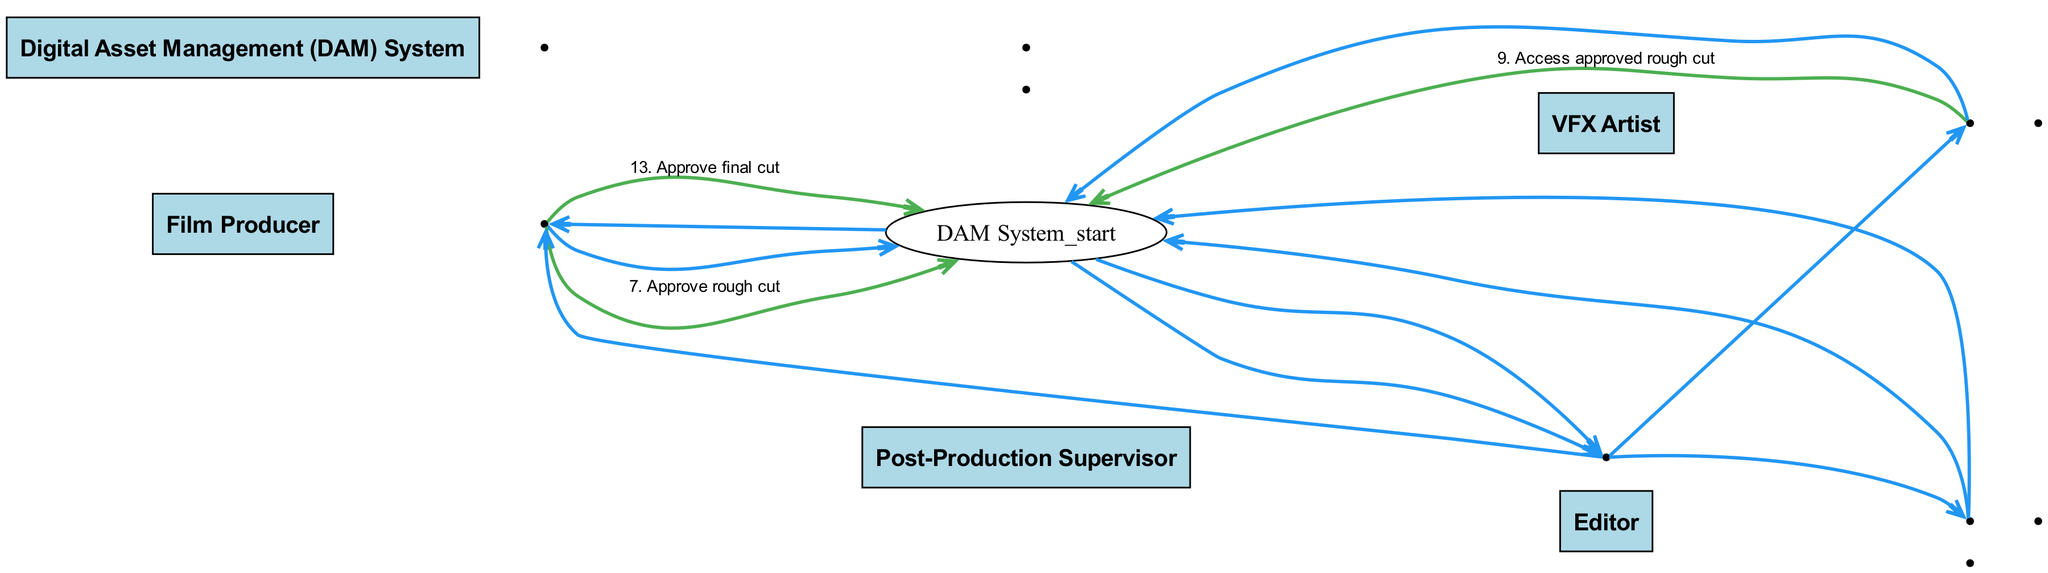What action does the Film Producer take first? The Film Producer initiates the process by uploading raw footage to the Digital Asset Management System. This is the first action in the sequence diagram.
Answer: Upload raw footage How many total actions are depicted in the sequence? The sequence consists of 13 actions represented by edges connecting different actors. These actions outline the workflow in the approval process.
Answer: 13 Who is assigned editing tasks by the Post-Production Supervisor? The Post-Production Supervisor directly assigns editing tasks to the Editor, as indicated by the action in the sequence diagram.
Answer: Editor What is the last action taken by the Film Producer? The final action taken by the Film Producer is to approve the final cut, which concludes the approval process in the sequence.
Answer: Approve final cut Which actor accesses the approved rough cut after VFX tasks are assigned? After the Post-Production Supervisor assigns VFX tasks, it is the VFX Artist who accesses the approved rough cut from the Digital Asset Management System.
Answer: VFX Artist What does the DAM System notify the Post-Production Supervisor about? The Digital Asset Management System notifies the Post-Production Supervisor about the completion of VFX tasks, indicating that the VFX shots are ready for review.
Answer: Notify VFX completion Which action is taken after the Editor uploads the rough cut? After the Editor uploads the rough cut, the Digital Asset Management System requests approval for that rough cut from the Film Producer, moving the process forward.
Answer: Request approval for rough cut Which system does the VFX Artist upload their completed work to? The VFX Artist uploads their VFX shots to the Digital Asset Management System, which serves as the central hub for managing and approving digital assets.
Answer: DAM System 